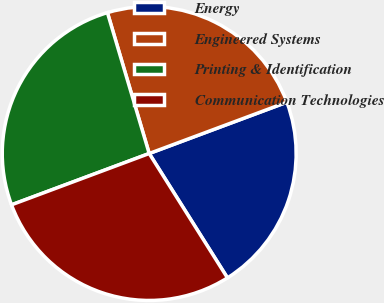Convert chart to OTSL. <chart><loc_0><loc_0><loc_500><loc_500><pie_chart><fcel>Energy<fcel>Engineered Systems<fcel>Printing & Identification<fcel>Communication Technologies<nl><fcel>21.74%<fcel>23.91%<fcel>26.09%<fcel>28.26%<nl></chart> 